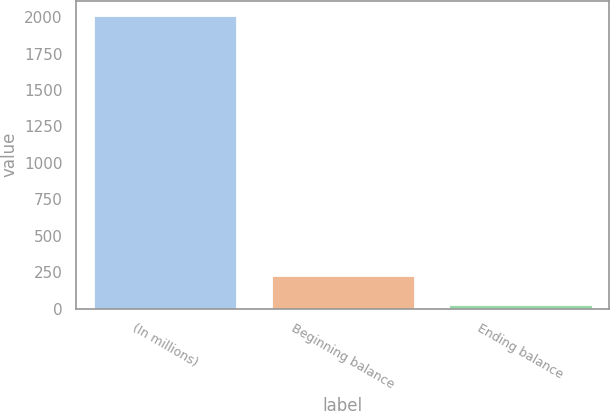Convert chart to OTSL. <chart><loc_0><loc_0><loc_500><loc_500><bar_chart><fcel>(In millions)<fcel>Beginning balance<fcel>Ending balance<nl><fcel>2011<fcel>220.9<fcel>22<nl></chart> 